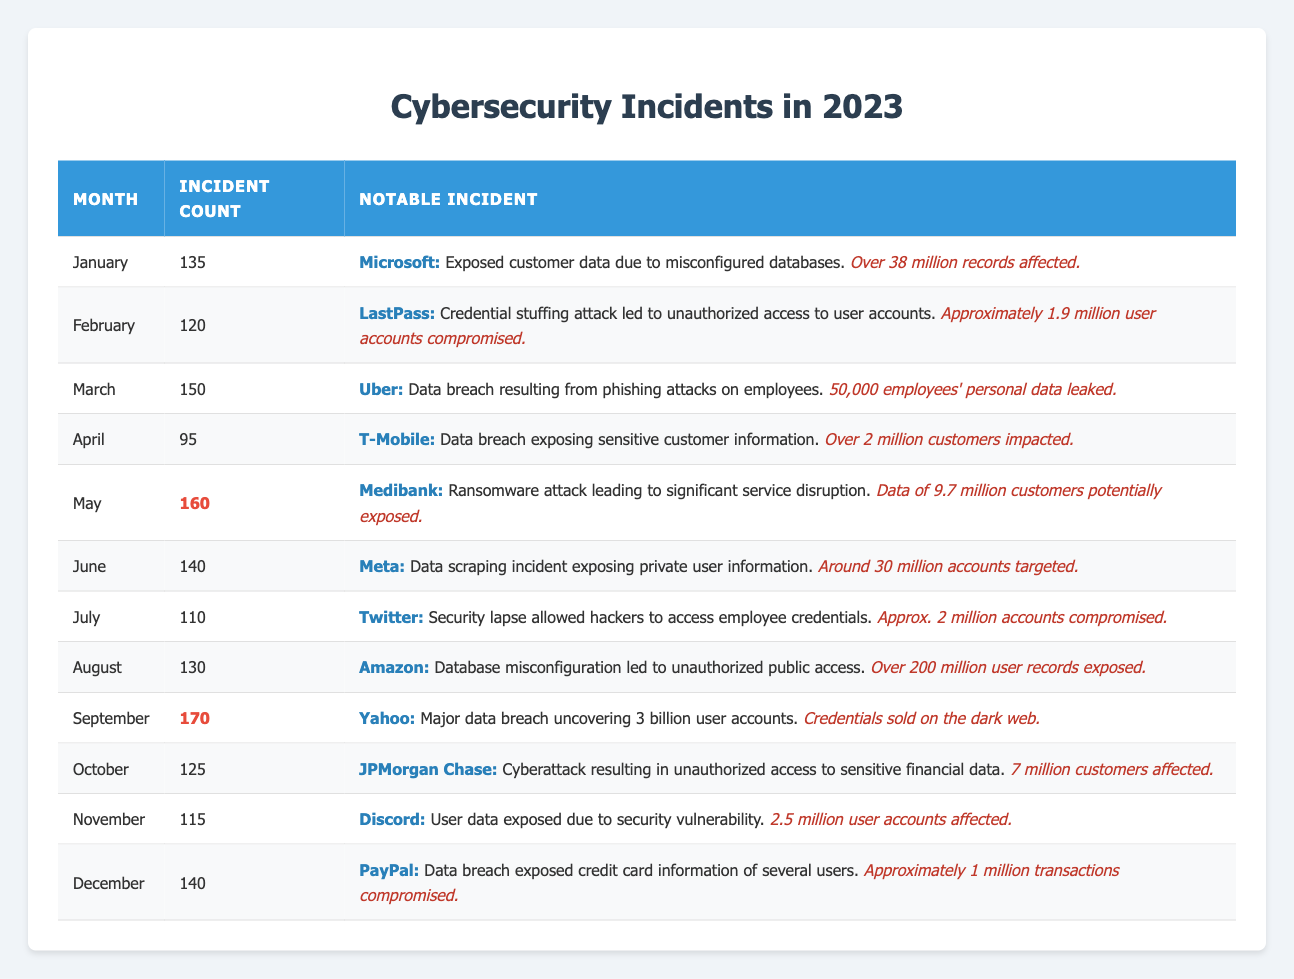What was the month with the highest incident count? By examining the incident counts for each month in the table, September has the highest count with 170 incidents.
Answer: September How many incidents occurred in May? According to the table, May recorded 160 cybersecurity incidents.
Answer: 160 Which company had a notable incident in February? The table indicates that LastPass had a notable incident in February.
Answer: LastPass How many incidents were reported in the first half of the year (January to June)? Adding the incident counts from January (135), February (120), March (150), April (95), May (160), and June (140) gives a total of 900 incidents for the first half of the year.
Answer: 900 Did T-Mobile have a higher or lower incident count than Twitter? T-Mobile had 95 incidents in April, while Twitter had 110 incidents in July, indicating that T-Mobile had a lower incident count than Twitter.
Answer: Lower What impact did the incident in March have on Uber? The notable incident in March involving Uber led to the leak of personal data for 50,000 employees.
Answer: 50,000 employees' data leaked What was the average incident count for the second half of the year (July to December)? The incident counts for the second half of the year are: July (110), August (130), September (170), October (125), November (115), December (140). Summing these gives 990, and dividing by 6 months results in an average of 165 incidents per month.
Answer: 165 Which incident involved the highest number of potentially affected users, and how many were impacted? Among the notable incidents in the table, the Medibank incident in May had the highest potential impact, with data of 9.7 million customers potentially exposed.
Answer: 9.7 million Did any incident in the table involve over 3 billion user accounts being compromised? Yes, the incident involving Yahoo in September uncovered a major data breach affecting 3 billion user accounts.
Answer: Yes How many incidents were reported in the months that had counts greater than 130? The months with incident counts greater than 130 are March (150), May (160), September (170), and August (130). Adding these gives us a total of 4 incidents.
Answer: 4 What is the difference in incident counts between September and April? The incident count for September is 170, and for April it is 95. Therefore, the difference is 170 - 95 = 75 incidents.
Answer: 75 